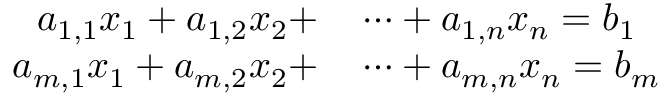Convert formula to latex. <formula><loc_0><loc_0><loc_500><loc_500>\begin{array} { r l } { a _ { 1 , 1 } x _ { 1 } + a _ { 1 , 2 } x _ { 2 } + } & \cdots + a _ { 1 , n } x _ { n } = b _ { 1 } } \\ { a _ { m , 1 } x _ { 1 } + a _ { m , 2 } x _ { 2 } + } & \cdots + a _ { m , n } x _ { n } = b _ { m } } \end{array}</formula> 